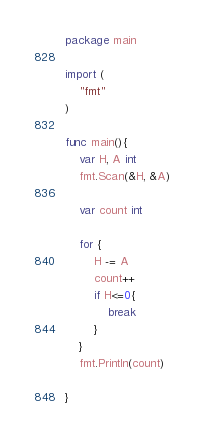<code> <loc_0><loc_0><loc_500><loc_500><_Go_>package main

import (
    "fmt"
)

func main(){
    var H, A int
    fmt.Scan(&H, &A)

    var count int

    for {
        H -= A
        count++
        if H<=0{
            break
        }
    }
    fmt.Println(count)
    
}
</code> 